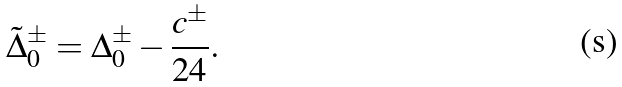Convert formula to latex. <formula><loc_0><loc_0><loc_500><loc_500>\tilde { \Delta } _ { 0 } ^ { \pm } = \Delta _ { 0 } ^ { \pm } - \frac { c ^ { \pm } } { 2 4 } .</formula> 